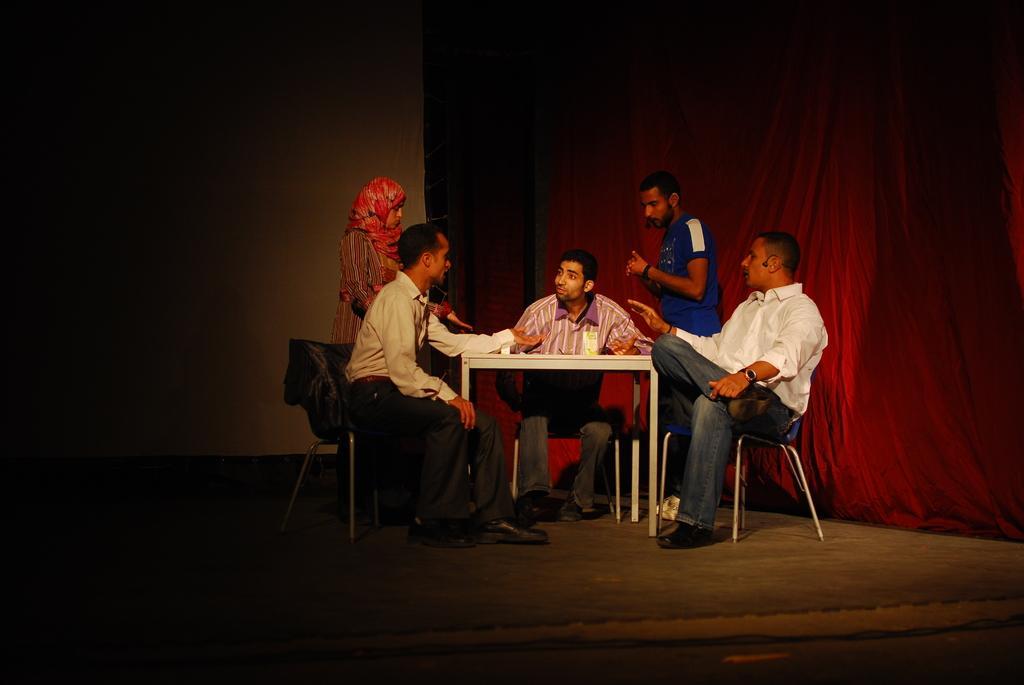Please provide a concise description of this image. In this image we can see a group of people sitting on the chairs beside a table containing an object on it. We can also see a man and a woman standing on the floor beside them. On the backside we can see a wall and a curtain. 